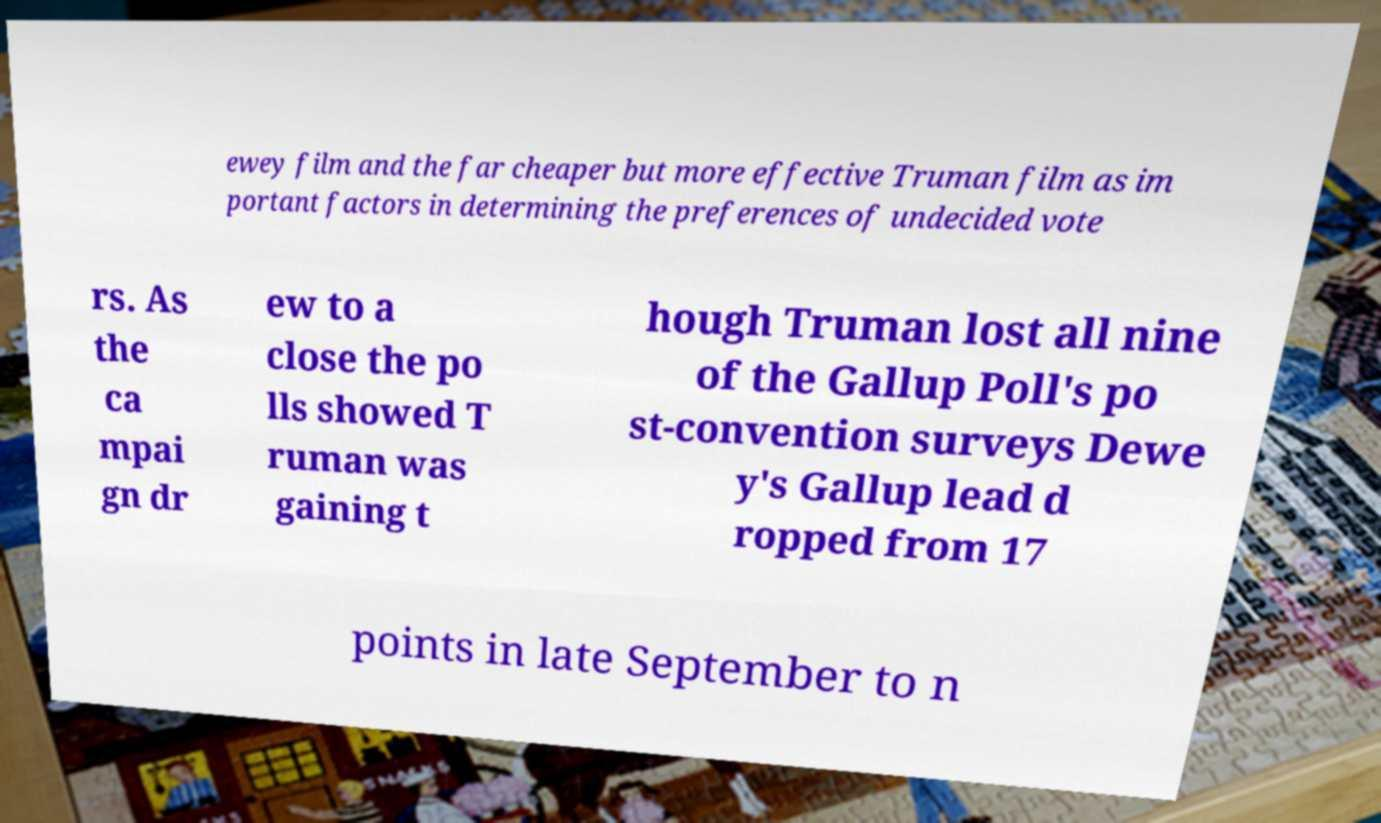There's text embedded in this image that I need extracted. Can you transcribe it verbatim? ewey film and the far cheaper but more effective Truman film as im portant factors in determining the preferences of undecided vote rs. As the ca mpai gn dr ew to a close the po lls showed T ruman was gaining t hough Truman lost all nine of the Gallup Poll's po st-convention surveys Dewe y's Gallup lead d ropped from 17 points in late September to n 